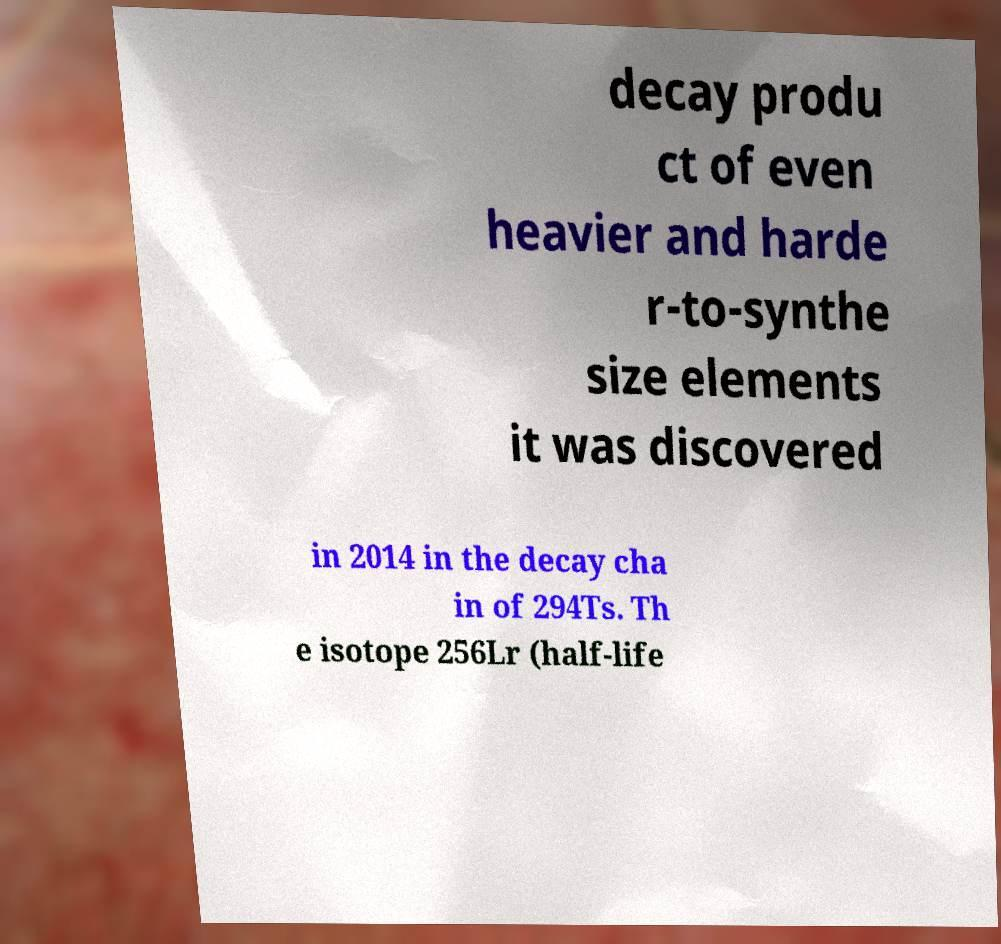What messages or text are displayed in this image? I need them in a readable, typed format. decay produ ct of even heavier and harde r-to-synthe size elements it was discovered in 2014 in the decay cha in of 294Ts. Th e isotope 256Lr (half-life 